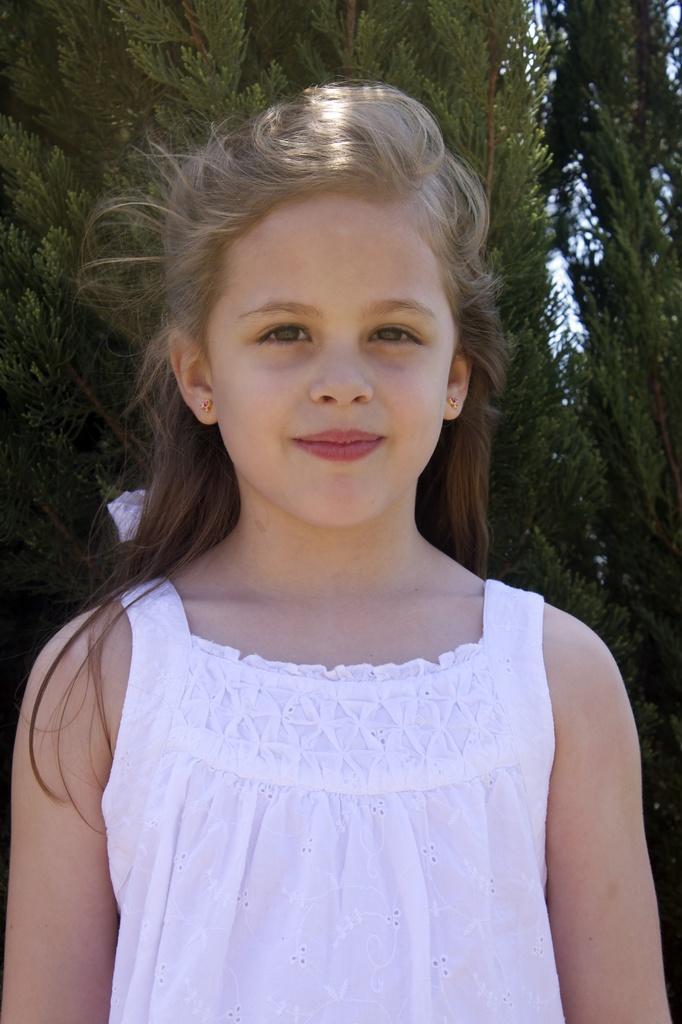In one or two sentences, can you explain what this image depicts? In this image I can see a girl who is wearing white dress is standing and in the background I can see few trees which are green in color and the sky. 